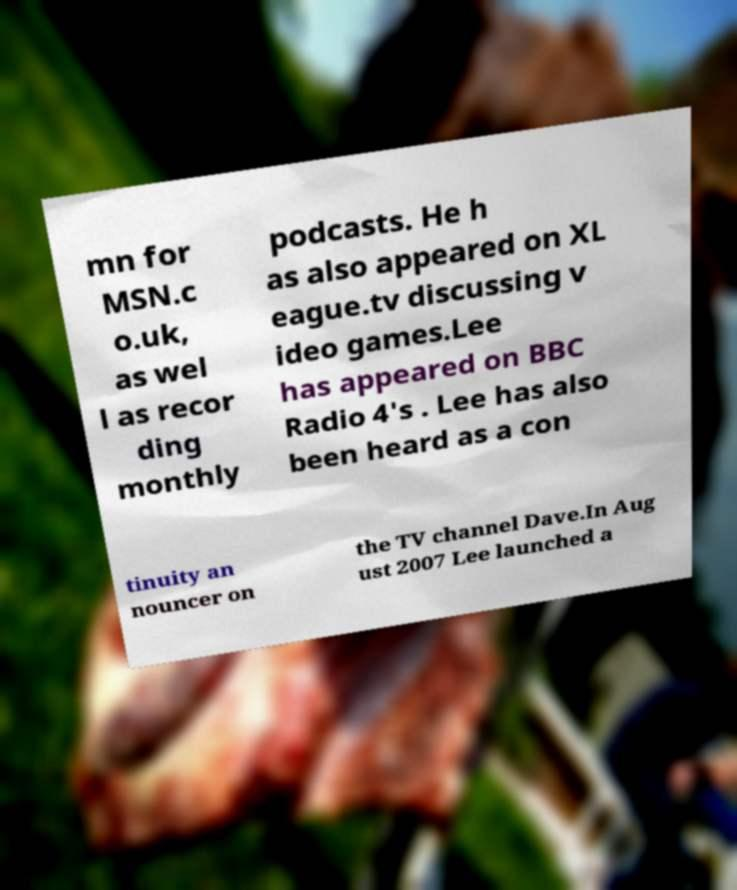I need the written content from this picture converted into text. Can you do that? mn for MSN.c o.uk, as wel l as recor ding monthly podcasts. He h as also appeared on XL eague.tv discussing v ideo games.Lee has appeared on BBC Radio 4's . Lee has also been heard as a con tinuity an nouncer on the TV channel Dave.In Aug ust 2007 Lee launched a 